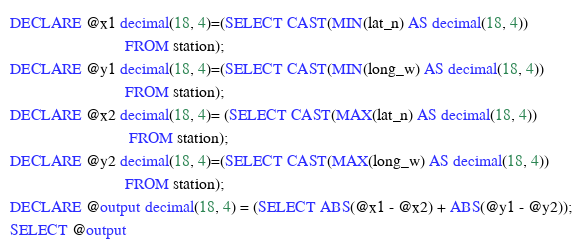<code> <loc_0><loc_0><loc_500><loc_500><_SQL_>DECLARE @x1 decimal(18, 4)=(SELECT CAST(MIN(lat_n) AS decimal(18, 4))
                            FROM station);
DECLARE @y1 decimal(18, 4)=(SELECT CAST(MIN(long_w) AS decimal(18, 4))
                            FROM station);
DECLARE @x2 decimal(18, 4)= (SELECT CAST(MAX(lat_n) AS decimal(18, 4))
                             FROM station);
DECLARE @y2 decimal(18, 4)=(SELECT CAST(MAX(long_w) AS decimal(18, 4))
                            FROM station);
DECLARE @output decimal(18, 4) = (SELECT ABS(@x1 - @x2) + ABS(@y1 - @y2));
SELECT @output</code> 